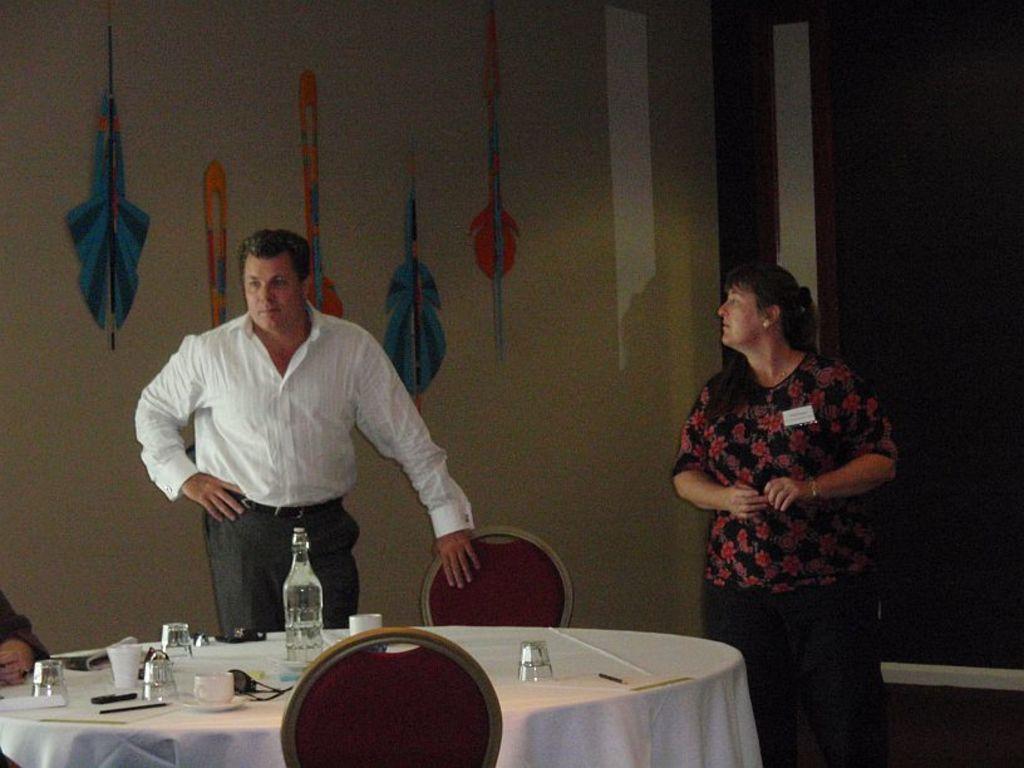How would you summarize this image in a sentence or two? There is a man and woman standing beside each other in front of table where some glasses and bottles are placed behind them there is a wall hanger. 